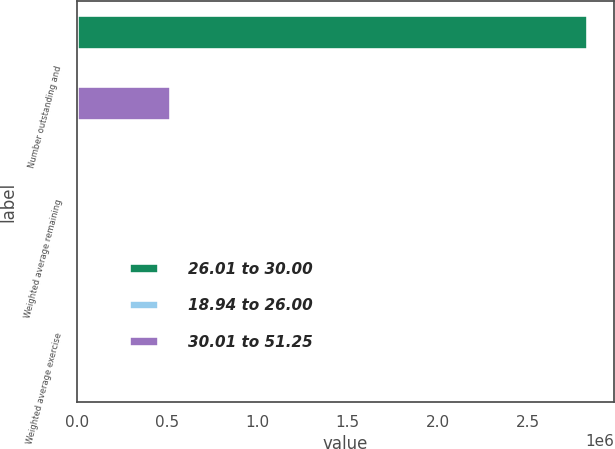Convert chart to OTSL. <chart><loc_0><loc_0><loc_500><loc_500><stacked_bar_chart><ecel><fcel>Number outstanding and<fcel>Weighted average remaining<fcel>Weighted average exercise<nl><fcel>26.01 to 30.00<fcel>2.8321e+06<fcel>2.2<fcel>23.73<nl><fcel>18.94 to 26.00<fcel>25.315<fcel>1.6<fcel>26.9<nl><fcel>30.01 to 51.25<fcel>523083<fcel>2.5<fcel>46.5<nl></chart> 